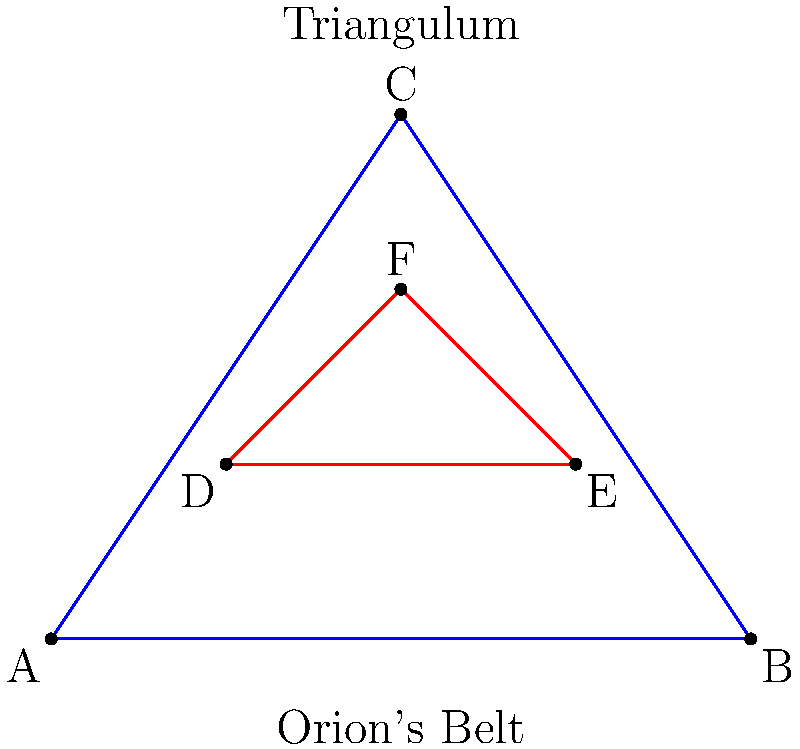In the night sky, the constellation Orion's Belt forms a triangle ABC, while the constellation Triangulum forms a smaller triangle DEF within it. If the area of triangle ABC is 6 square units and the area of triangle DEF is 1 square unit, what is the ratio of the side lengths of triangle DEF to the corresponding side lengths of triangle ABC? Let's approach this step-by-step:

1) First, recall that for similar triangles, the ratio of their areas is equal to the square of the ratio of their corresponding side lengths. Let's call this ratio $r$.

2) We can express this relationship mathematically:
   $$\frac{\text{Area of DEF}}{\text{Area of ABC}} = r^2$$

3) We're given that the area of ABC is 6 square units and the area of DEF is 1 square unit. Let's substitute these values:
   $$\frac{1}{6} = r^2$$

4) To solve for $r$, we take the square root of both sides:
   $$r = \sqrt{\frac{1}{6}} = \frac{1}{\sqrt{6}}$$

5) We can simplify this further:
   $$r = \frac{1}{\sqrt{6}} = \frac{\sqrt{6}}{6} = \frac{\sqrt{6}}{2\sqrt{3}} = \frac{1}{2\sqrt{\frac{1}{2}}}$$

6) Therefore, the ratio of the side lengths of triangle DEF to the corresponding side lengths of triangle ABC is $1 : 2\sqrt{\frac{1}{2}}$, or simplified, $\sqrt{2} : 2\sqrt{1}$.

This ratio applies to all corresponding sides of the two triangles.
Answer: $\sqrt{2} : 2\sqrt{1}$ 